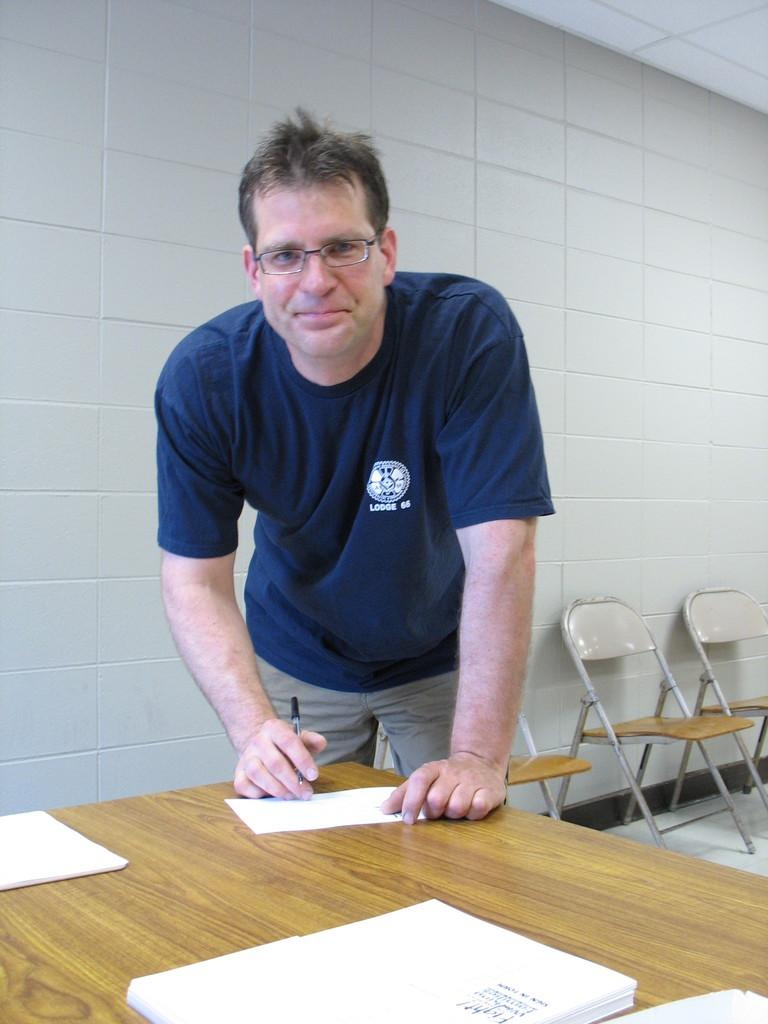<image>
Render a clear and concise summary of the photo. A man is wearing a Lodge 66 t-shirt. 